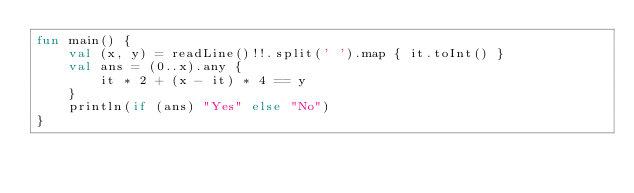Convert code to text. <code><loc_0><loc_0><loc_500><loc_500><_Kotlin_>fun main() {
    val (x, y) = readLine()!!.split(' ').map { it.toInt() }
    val ans = (0..x).any {
        it * 2 + (x - it) * 4 == y
    }
    println(if (ans) "Yes" else "No")
}</code> 